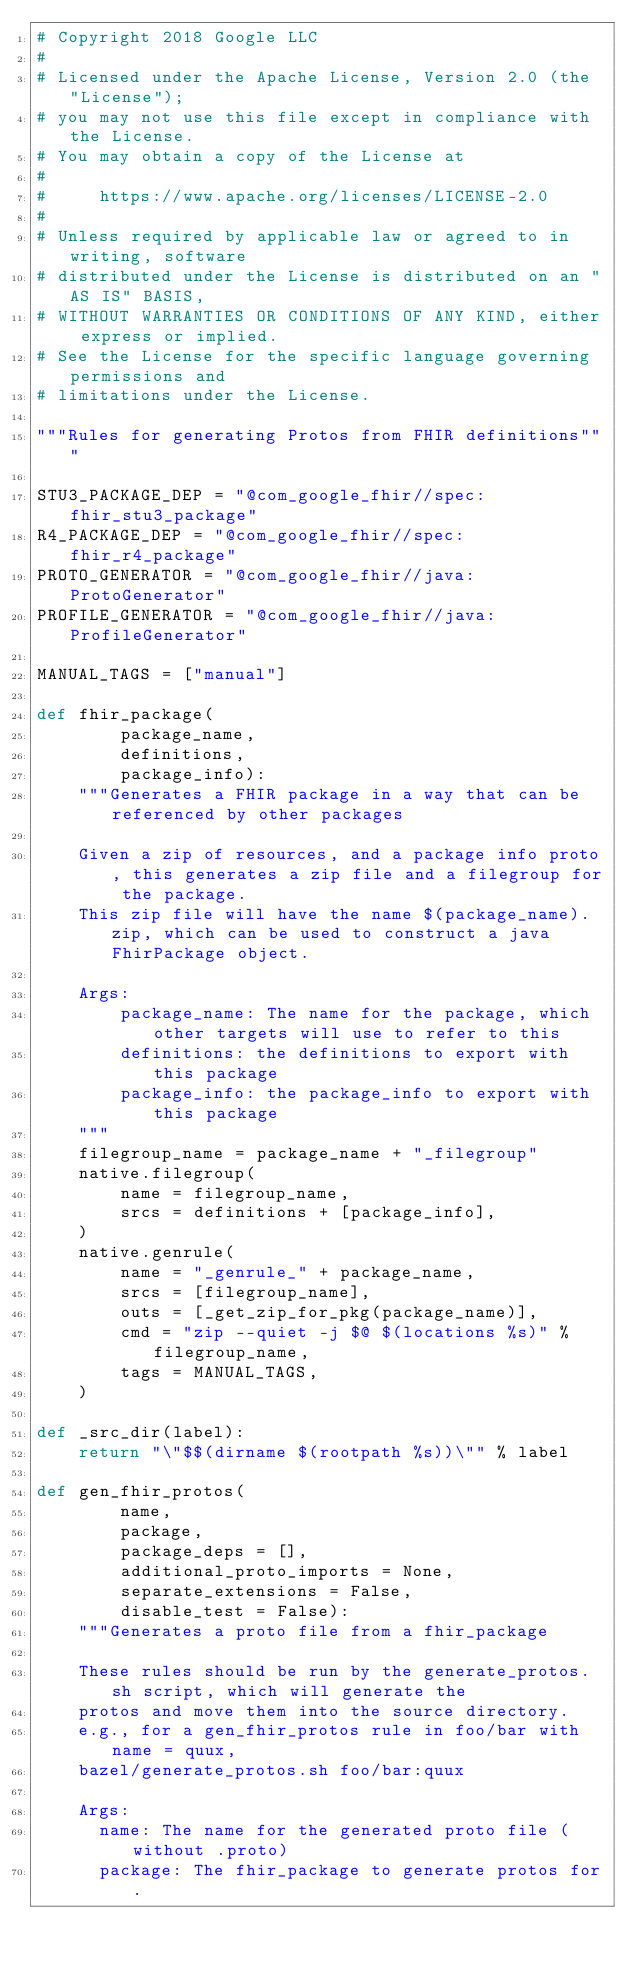<code> <loc_0><loc_0><loc_500><loc_500><_Python_># Copyright 2018 Google LLC
#
# Licensed under the Apache License, Version 2.0 (the "License");
# you may not use this file except in compliance with the License.
# You may obtain a copy of the License at
#
#     https://www.apache.org/licenses/LICENSE-2.0
#
# Unless required by applicable law or agreed to in writing, software
# distributed under the License is distributed on an "AS IS" BASIS,
# WITHOUT WARRANTIES OR CONDITIONS OF ANY KIND, either express or implied.
# See the License for the specific language governing permissions and
# limitations under the License.

"""Rules for generating Protos from FHIR definitions"""

STU3_PACKAGE_DEP = "@com_google_fhir//spec:fhir_stu3_package"
R4_PACKAGE_DEP = "@com_google_fhir//spec:fhir_r4_package"
PROTO_GENERATOR = "@com_google_fhir//java:ProtoGenerator"
PROFILE_GENERATOR = "@com_google_fhir//java:ProfileGenerator"

MANUAL_TAGS = ["manual"]

def fhir_package(
        package_name,
        definitions,
        package_info):
    """Generates a FHIR package in a way that can be referenced by other packages

    Given a zip of resources, and a package info proto, this generates a zip file and a filegroup for the package.
    This zip file will have the name $(package_name).zip, which can be used to construct a java FhirPackage object.

    Args:
        package_name: The name for the package, which other targets will use to refer to this
        definitions: the definitions to export with this package
        package_info: the package_info to export with this package
    """
    filegroup_name = package_name + "_filegroup"
    native.filegroup(
        name = filegroup_name,
        srcs = definitions + [package_info],
    )
    native.genrule(
        name = "_genrule_" + package_name,
        srcs = [filegroup_name],
        outs = [_get_zip_for_pkg(package_name)],
        cmd = "zip --quiet -j $@ $(locations %s)" % filegroup_name,
        tags = MANUAL_TAGS,
    )

def _src_dir(label):
    return "\"$$(dirname $(rootpath %s))\"" % label

def gen_fhir_protos(
        name,
        package,
        package_deps = [],
        additional_proto_imports = None,
        separate_extensions = False,
        disable_test = False):
    """Generates a proto file from a fhir_package

    These rules should be run by the generate_protos.sh script, which will generate the
    protos and move them into the source directory.
    e.g., for a gen_fhir_protos rule in foo/bar with name = quux,
    bazel/generate_protos.sh foo/bar:quux

    Args:
      name: The name for the generated proto file (without .proto)
      package: The fhir_package to generate protos for.</code> 